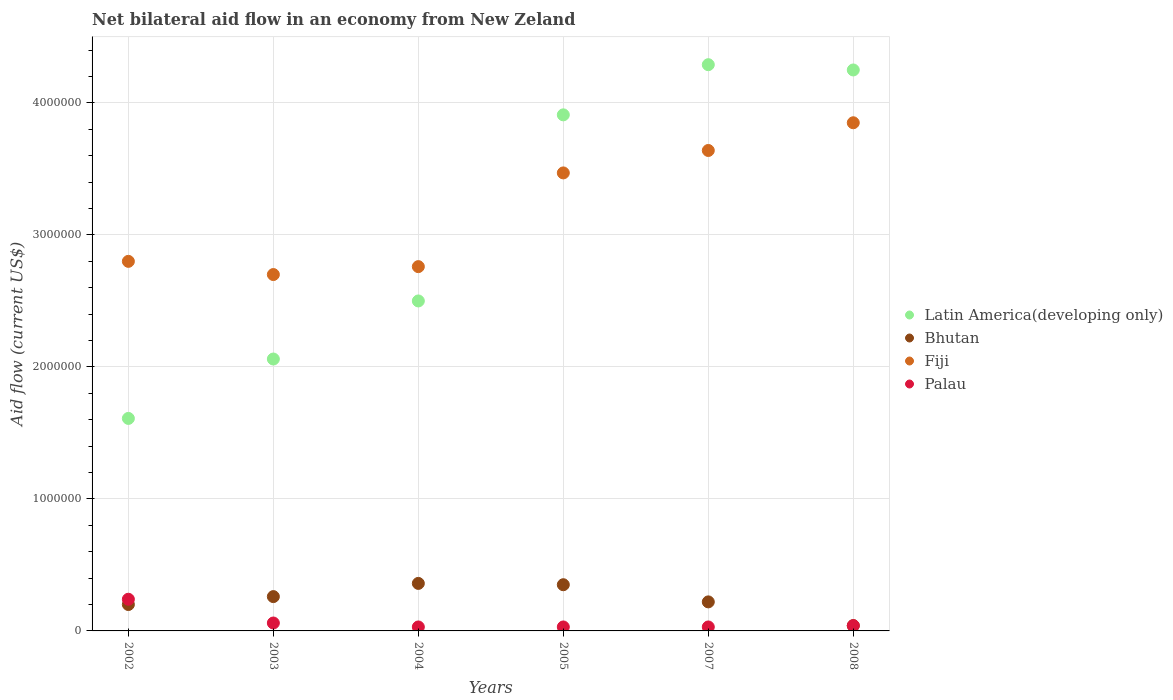How many different coloured dotlines are there?
Keep it short and to the point. 4. What is the net bilateral aid flow in Latin America(developing only) in 2005?
Your response must be concise. 3.91e+06. In which year was the net bilateral aid flow in Fiji minimum?
Your answer should be compact. 2003. What is the total net bilateral aid flow in Fiji in the graph?
Your answer should be very brief. 1.92e+07. What is the difference between the net bilateral aid flow in Fiji in 2004 and the net bilateral aid flow in Bhutan in 2007?
Your response must be concise. 2.54e+06. What is the average net bilateral aid flow in Fiji per year?
Keep it short and to the point. 3.20e+06. In the year 2004, what is the difference between the net bilateral aid flow in Palau and net bilateral aid flow in Bhutan?
Your response must be concise. -3.30e+05. What is the ratio of the net bilateral aid flow in Latin America(developing only) in 2005 to that in 2008?
Ensure brevity in your answer.  0.92. What is the difference between the highest and the lowest net bilateral aid flow in Latin America(developing only)?
Make the answer very short. 2.68e+06. In how many years, is the net bilateral aid flow in Fiji greater than the average net bilateral aid flow in Fiji taken over all years?
Give a very brief answer. 3. Does the net bilateral aid flow in Bhutan monotonically increase over the years?
Your answer should be compact. No. Is the net bilateral aid flow in Bhutan strictly greater than the net bilateral aid flow in Fiji over the years?
Your answer should be very brief. No. What is the difference between two consecutive major ticks on the Y-axis?
Provide a succinct answer. 1.00e+06. Are the values on the major ticks of Y-axis written in scientific E-notation?
Your response must be concise. No. Does the graph contain any zero values?
Provide a succinct answer. No. How many legend labels are there?
Keep it short and to the point. 4. How are the legend labels stacked?
Offer a terse response. Vertical. What is the title of the graph?
Offer a terse response. Net bilateral aid flow in an economy from New Zeland. What is the label or title of the Y-axis?
Your response must be concise. Aid flow (current US$). What is the Aid flow (current US$) in Latin America(developing only) in 2002?
Give a very brief answer. 1.61e+06. What is the Aid flow (current US$) in Fiji in 2002?
Make the answer very short. 2.80e+06. What is the Aid flow (current US$) in Palau in 2002?
Make the answer very short. 2.40e+05. What is the Aid flow (current US$) in Latin America(developing only) in 2003?
Offer a terse response. 2.06e+06. What is the Aid flow (current US$) of Bhutan in 2003?
Offer a terse response. 2.60e+05. What is the Aid flow (current US$) in Fiji in 2003?
Your response must be concise. 2.70e+06. What is the Aid flow (current US$) in Palau in 2003?
Give a very brief answer. 6.00e+04. What is the Aid flow (current US$) of Latin America(developing only) in 2004?
Give a very brief answer. 2.50e+06. What is the Aid flow (current US$) in Fiji in 2004?
Provide a short and direct response. 2.76e+06. What is the Aid flow (current US$) of Latin America(developing only) in 2005?
Provide a short and direct response. 3.91e+06. What is the Aid flow (current US$) of Bhutan in 2005?
Provide a short and direct response. 3.50e+05. What is the Aid flow (current US$) of Fiji in 2005?
Give a very brief answer. 3.47e+06. What is the Aid flow (current US$) in Latin America(developing only) in 2007?
Ensure brevity in your answer.  4.29e+06. What is the Aid flow (current US$) in Fiji in 2007?
Offer a terse response. 3.64e+06. What is the Aid flow (current US$) in Palau in 2007?
Keep it short and to the point. 3.00e+04. What is the Aid flow (current US$) in Latin America(developing only) in 2008?
Make the answer very short. 4.25e+06. What is the Aid flow (current US$) of Bhutan in 2008?
Your response must be concise. 4.00e+04. What is the Aid flow (current US$) of Fiji in 2008?
Make the answer very short. 3.85e+06. What is the Aid flow (current US$) of Palau in 2008?
Give a very brief answer. 4.00e+04. Across all years, what is the maximum Aid flow (current US$) in Latin America(developing only)?
Give a very brief answer. 4.29e+06. Across all years, what is the maximum Aid flow (current US$) in Bhutan?
Offer a very short reply. 3.60e+05. Across all years, what is the maximum Aid flow (current US$) of Fiji?
Your response must be concise. 3.85e+06. Across all years, what is the maximum Aid flow (current US$) in Palau?
Your answer should be very brief. 2.40e+05. Across all years, what is the minimum Aid flow (current US$) in Latin America(developing only)?
Offer a very short reply. 1.61e+06. Across all years, what is the minimum Aid flow (current US$) of Fiji?
Provide a succinct answer. 2.70e+06. Across all years, what is the minimum Aid flow (current US$) of Palau?
Your answer should be compact. 3.00e+04. What is the total Aid flow (current US$) of Latin America(developing only) in the graph?
Provide a short and direct response. 1.86e+07. What is the total Aid flow (current US$) of Bhutan in the graph?
Give a very brief answer. 1.43e+06. What is the total Aid flow (current US$) in Fiji in the graph?
Provide a succinct answer. 1.92e+07. What is the total Aid flow (current US$) of Palau in the graph?
Your answer should be compact. 4.30e+05. What is the difference between the Aid flow (current US$) of Latin America(developing only) in 2002 and that in 2003?
Your answer should be compact. -4.50e+05. What is the difference between the Aid flow (current US$) of Latin America(developing only) in 2002 and that in 2004?
Make the answer very short. -8.90e+05. What is the difference between the Aid flow (current US$) of Bhutan in 2002 and that in 2004?
Your response must be concise. -1.60e+05. What is the difference between the Aid flow (current US$) in Palau in 2002 and that in 2004?
Keep it short and to the point. 2.10e+05. What is the difference between the Aid flow (current US$) of Latin America(developing only) in 2002 and that in 2005?
Offer a terse response. -2.30e+06. What is the difference between the Aid flow (current US$) of Bhutan in 2002 and that in 2005?
Make the answer very short. -1.50e+05. What is the difference between the Aid flow (current US$) of Fiji in 2002 and that in 2005?
Your response must be concise. -6.70e+05. What is the difference between the Aid flow (current US$) in Palau in 2002 and that in 2005?
Give a very brief answer. 2.10e+05. What is the difference between the Aid flow (current US$) in Latin America(developing only) in 2002 and that in 2007?
Provide a short and direct response. -2.68e+06. What is the difference between the Aid flow (current US$) of Bhutan in 2002 and that in 2007?
Keep it short and to the point. -2.00e+04. What is the difference between the Aid flow (current US$) in Fiji in 2002 and that in 2007?
Provide a succinct answer. -8.40e+05. What is the difference between the Aid flow (current US$) in Palau in 2002 and that in 2007?
Provide a succinct answer. 2.10e+05. What is the difference between the Aid flow (current US$) in Latin America(developing only) in 2002 and that in 2008?
Offer a very short reply. -2.64e+06. What is the difference between the Aid flow (current US$) of Fiji in 2002 and that in 2008?
Your answer should be very brief. -1.05e+06. What is the difference between the Aid flow (current US$) in Palau in 2002 and that in 2008?
Make the answer very short. 2.00e+05. What is the difference between the Aid flow (current US$) of Latin America(developing only) in 2003 and that in 2004?
Provide a short and direct response. -4.40e+05. What is the difference between the Aid flow (current US$) in Fiji in 2003 and that in 2004?
Give a very brief answer. -6.00e+04. What is the difference between the Aid flow (current US$) in Palau in 2003 and that in 2004?
Make the answer very short. 3.00e+04. What is the difference between the Aid flow (current US$) of Latin America(developing only) in 2003 and that in 2005?
Your response must be concise. -1.85e+06. What is the difference between the Aid flow (current US$) in Fiji in 2003 and that in 2005?
Your answer should be compact. -7.70e+05. What is the difference between the Aid flow (current US$) of Palau in 2003 and that in 2005?
Your response must be concise. 3.00e+04. What is the difference between the Aid flow (current US$) in Latin America(developing only) in 2003 and that in 2007?
Provide a short and direct response. -2.23e+06. What is the difference between the Aid flow (current US$) in Bhutan in 2003 and that in 2007?
Your answer should be compact. 4.00e+04. What is the difference between the Aid flow (current US$) of Fiji in 2003 and that in 2007?
Make the answer very short. -9.40e+05. What is the difference between the Aid flow (current US$) of Palau in 2003 and that in 2007?
Give a very brief answer. 3.00e+04. What is the difference between the Aid flow (current US$) in Latin America(developing only) in 2003 and that in 2008?
Offer a very short reply. -2.19e+06. What is the difference between the Aid flow (current US$) of Bhutan in 2003 and that in 2008?
Give a very brief answer. 2.20e+05. What is the difference between the Aid flow (current US$) of Fiji in 2003 and that in 2008?
Your answer should be compact. -1.15e+06. What is the difference between the Aid flow (current US$) in Palau in 2003 and that in 2008?
Your response must be concise. 2.00e+04. What is the difference between the Aid flow (current US$) in Latin America(developing only) in 2004 and that in 2005?
Offer a very short reply. -1.41e+06. What is the difference between the Aid flow (current US$) of Bhutan in 2004 and that in 2005?
Your answer should be very brief. 10000. What is the difference between the Aid flow (current US$) of Fiji in 2004 and that in 2005?
Offer a terse response. -7.10e+05. What is the difference between the Aid flow (current US$) of Latin America(developing only) in 2004 and that in 2007?
Your answer should be compact. -1.79e+06. What is the difference between the Aid flow (current US$) in Fiji in 2004 and that in 2007?
Your response must be concise. -8.80e+05. What is the difference between the Aid flow (current US$) in Latin America(developing only) in 2004 and that in 2008?
Your response must be concise. -1.75e+06. What is the difference between the Aid flow (current US$) in Fiji in 2004 and that in 2008?
Ensure brevity in your answer.  -1.09e+06. What is the difference between the Aid flow (current US$) in Palau in 2004 and that in 2008?
Offer a terse response. -10000. What is the difference between the Aid flow (current US$) in Latin America(developing only) in 2005 and that in 2007?
Ensure brevity in your answer.  -3.80e+05. What is the difference between the Aid flow (current US$) in Fiji in 2005 and that in 2007?
Make the answer very short. -1.70e+05. What is the difference between the Aid flow (current US$) in Palau in 2005 and that in 2007?
Offer a very short reply. 0. What is the difference between the Aid flow (current US$) of Latin America(developing only) in 2005 and that in 2008?
Provide a succinct answer. -3.40e+05. What is the difference between the Aid flow (current US$) of Bhutan in 2005 and that in 2008?
Give a very brief answer. 3.10e+05. What is the difference between the Aid flow (current US$) of Fiji in 2005 and that in 2008?
Your answer should be compact. -3.80e+05. What is the difference between the Aid flow (current US$) of Latin America(developing only) in 2007 and that in 2008?
Your response must be concise. 4.00e+04. What is the difference between the Aid flow (current US$) of Bhutan in 2007 and that in 2008?
Your answer should be compact. 1.80e+05. What is the difference between the Aid flow (current US$) of Fiji in 2007 and that in 2008?
Keep it short and to the point. -2.10e+05. What is the difference between the Aid flow (current US$) of Latin America(developing only) in 2002 and the Aid flow (current US$) of Bhutan in 2003?
Your answer should be compact. 1.35e+06. What is the difference between the Aid flow (current US$) of Latin America(developing only) in 2002 and the Aid flow (current US$) of Fiji in 2003?
Offer a terse response. -1.09e+06. What is the difference between the Aid flow (current US$) of Latin America(developing only) in 2002 and the Aid flow (current US$) of Palau in 2003?
Your answer should be compact. 1.55e+06. What is the difference between the Aid flow (current US$) in Bhutan in 2002 and the Aid flow (current US$) in Fiji in 2003?
Make the answer very short. -2.50e+06. What is the difference between the Aid flow (current US$) in Bhutan in 2002 and the Aid flow (current US$) in Palau in 2003?
Provide a succinct answer. 1.40e+05. What is the difference between the Aid flow (current US$) of Fiji in 2002 and the Aid flow (current US$) of Palau in 2003?
Offer a terse response. 2.74e+06. What is the difference between the Aid flow (current US$) of Latin America(developing only) in 2002 and the Aid flow (current US$) of Bhutan in 2004?
Make the answer very short. 1.25e+06. What is the difference between the Aid flow (current US$) in Latin America(developing only) in 2002 and the Aid flow (current US$) in Fiji in 2004?
Offer a terse response. -1.15e+06. What is the difference between the Aid flow (current US$) in Latin America(developing only) in 2002 and the Aid flow (current US$) in Palau in 2004?
Make the answer very short. 1.58e+06. What is the difference between the Aid flow (current US$) in Bhutan in 2002 and the Aid flow (current US$) in Fiji in 2004?
Provide a succinct answer. -2.56e+06. What is the difference between the Aid flow (current US$) of Fiji in 2002 and the Aid flow (current US$) of Palau in 2004?
Make the answer very short. 2.77e+06. What is the difference between the Aid flow (current US$) in Latin America(developing only) in 2002 and the Aid flow (current US$) in Bhutan in 2005?
Offer a very short reply. 1.26e+06. What is the difference between the Aid flow (current US$) in Latin America(developing only) in 2002 and the Aid flow (current US$) in Fiji in 2005?
Your answer should be compact. -1.86e+06. What is the difference between the Aid flow (current US$) of Latin America(developing only) in 2002 and the Aid flow (current US$) of Palau in 2005?
Ensure brevity in your answer.  1.58e+06. What is the difference between the Aid flow (current US$) of Bhutan in 2002 and the Aid flow (current US$) of Fiji in 2005?
Provide a succinct answer. -3.27e+06. What is the difference between the Aid flow (current US$) of Bhutan in 2002 and the Aid flow (current US$) of Palau in 2005?
Keep it short and to the point. 1.70e+05. What is the difference between the Aid flow (current US$) in Fiji in 2002 and the Aid flow (current US$) in Palau in 2005?
Provide a succinct answer. 2.77e+06. What is the difference between the Aid flow (current US$) of Latin America(developing only) in 2002 and the Aid flow (current US$) of Bhutan in 2007?
Your answer should be very brief. 1.39e+06. What is the difference between the Aid flow (current US$) of Latin America(developing only) in 2002 and the Aid flow (current US$) of Fiji in 2007?
Ensure brevity in your answer.  -2.03e+06. What is the difference between the Aid flow (current US$) of Latin America(developing only) in 2002 and the Aid flow (current US$) of Palau in 2007?
Keep it short and to the point. 1.58e+06. What is the difference between the Aid flow (current US$) in Bhutan in 2002 and the Aid flow (current US$) in Fiji in 2007?
Keep it short and to the point. -3.44e+06. What is the difference between the Aid flow (current US$) of Fiji in 2002 and the Aid flow (current US$) of Palau in 2007?
Your answer should be very brief. 2.77e+06. What is the difference between the Aid flow (current US$) in Latin America(developing only) in 2002 and the Aid flow (current US$) in Bhutan in 2008?
Ensure brevity in your answer.  1.57e+06. What is the difference between the Aid flow (current US$) in Latin America(developing only) in 2002 and the Aid flow (current US$) in Fiji in 2008?
Give a very brief answer. -2.24e+06. What is the difference between the Aid flow (current US$) in Latin America(developing only) in 2002 and the Aid flow (current US$) in Palau in 2008?
Your response must be concise. 1.57e+06. What is the difference between the Aid flow (current US$) in Bhutan in 2002 and the Aid flow (current US$) in Fiji in 2008?
Ensure brevity in your answer.  -3.65e+06. What is the difference between the Aid flow (current US$) of Fiji in 2002 and the Aid flow (current US$) of Palau in 2008?
Ensure brevity in your answer.  2.76e+06. What is the difference between the Aid flow (current US$) of Latin America(developing only) in 2003 and the Aid flow (current US$) of Bhutan in 2004?
Your answer should be compact. 1.70e+06. What is the difference between the Aid flow (current US$) of Latin America(developing only) in 2003 and the Aid flow (current US$) of Fiji in 2004?
Offer a terse response. -7.00e+05. What is the difference between the Aid flow (current US$) in Latin America(developing only) in 2003 and the Aid flow (current US$) in Palau in 2004?
Your answer should be compact. 2.03e+06. What is the difference between the Aid flow (current US$) of Bhutan in 2003 and the Aid flow (current US$) of Fiji in 2004?
Offer a terse response. -2.50e+06. What is the difference between the Aid flow (current US$) in Fiji in 2003 and the Aid flow (current US$) in Palau in 2004?
Keep it short and to the point. 2.67e+06. What is the difference between the Aid flow (current US$) in Latin America(developing only) in 2003 and the Aid flow (current US$) in Bhutan in 2005?
Keep it short and to the point. 1.71e+06. What is the difference between the Aid flow (current US$) in Latin America(developing only) in 2003 and the Aid flow (current US$) in Fiji in 2005?
Offer a terse response. -1.41e+06. What is the difference between the Aid flow (current US$) of Latin America(developing only) in 2003 and the Aid flow (current US$) of Palau in 2005?
Keep it short and to the point. 2.03e+06. What is the difference between the Aid flow (current US$) of Bhutan in 2003 and the Aid flow (current US$) of Fiji in 2005?
Give a very brief answer. -3.21e+06. What is the difference between the Aid flow (current US$) of Fiji in 2003 and the Aid flow (current US$) of Palau in 2005?
Ensure brevity in your answer.  2.67e+06. What is the difference between the Aid flow (current US$) of Latin America(developing only) in 2003 and the Aid flow (current US$) of Bhutan in 2007?
Offer a terse response. 1.84e+06. What is the difference between the Aid flow (current US$) of Latin America(developing only) in 2003 and the Aid flow (current US$) of Fiji in 2007?
Give a very brief answer. -1.58e+06. What is the difference between the Aid flow (current US$) in Latin America(developing only) in 2003 and the Aid flow (current US$) in Palau in 2007?
Keep it short and to the point. 2.03e+06. What is the difference between the Aid flow (current US$) in Bhutan in 2003 and the Aid flow (current US$) in Fiji in 2007?
Offer a very short reply. -3.38e+06. What is the difference between the Aid flow (current US$) of Bhutan in 2003 and the Aid flow (current US$) of Palau in 2007?
Offer a terse response. 2.30e+05. What is the difference between the Aid flow (current US$) in Fiji in 2003 and the Aid flow (current US$) in Palau in 2007?
Make the answer very short. 2.67e+06. What is the difference between the Aid flow (current US$) of Latin America(developing only) in 2003 and the Aid flow (current US$) of Bhutan in 2008?
Offer a very short reply. 2.02e+06. What is the difference between the Aid flow (current US$) in Latin America(developing only) in 2003 and the Aid flow (current US$) in Fiji in 2008?
Your response must be concise. -1.79e+06. What is the difference between the Aid flow (current US$) of Latin America(developing only) in 2003 and the Aid flow (current US$) of Palau in 2008?
Provide a succinct answer. 2.02e+06. What is the difference between the Aid flow (current US$) in Bhutan in 2003 and the Aid flow (current US$) in Fiji in 2008?
Your answer should be compact. -3.59e+06. What is the difference between the Aid flow (current US$) in Fiji in 2003 and the Aid flow (current US$) in Palau in 2008?
Ensure brevity in your answer.  2.66e+06. What is the difference between the Aid flow (current US$) in Latin America(developing only) in 2004 and the Aid flow (current US$) in Bhutan in 2005?
Your response must be concise. 2.15e+06. What is the difference between the Aid flow (current US$) in Latin America(developing only) in 2004 and the Aid flow (current US$) in Fiji in 2005?
Provide a succinct answer. -9.70e+05. What is the difference between the Aid flow (current US$) in Latin America(developing only) in 2004 and the Aid flow (current US$) in Palau in 2005?
Provide a short and direct response. 2.47e+06. What is the difference between the Aid flow (current US$) of Bhutan in 2004 and the Aid flow (current US$) of Fiji in 2005?
Offer a very short reply. -3.11e+06. What is the difference between the Aid flow (current US$) of Fiji in 2004 and the Aid flow (current US$) of Palau in 2005?
Your answer should be compact. 2.73e+06. What is the difference between the Aid flow (current US$) in Latin America(developing only) in 2004 and the Aid flow (current US$) in Bhutan in 2007?
Offer a terse response. 2.28e+06. What is the difference between the Aid flow (current US$) in Latin America(developing only) in 2004 and the Aid flow (current US$) in Fiji in 2007?
Keep it short and to the point. -1.14e+06. What is the difference between the Aid flow (current US$) in Latin America(developing only) in 2004 and the Aid flow (current US$) in Palau in 2007?
Ensure brevity in your answer.  2.47e+06. What is the difference between the Aid flow (current US$) in Bhutan in 2004 and the Aid flow (current US$) in Fiji in 2007?
Your answer should be very brief. -3.28e+06. What is the difference between the Aid flow (current US$) of Bhutan in 2004 and the Aid flow (current US$) of Palau in 2007?
Keep it short and to the point. 3.30e+05. What is the difference between the Aid flow (current US$) of Fiji in 2004 and the Aid flow (current US$) of Palau in 2007?
Your answer should be compact. 2.73e+06. What is the difference between the Aid flow (current US$) of Latin America(developing only) in 2004 and the Aid flow (current US$) of Bhutan in 2008?
Your response must be concise. 2.46e+06. What is the difference between the Aid flow (current US$) in Latin America(developing only) in 2004 and the Aid flow (current US$) in Fiji in 2008?
Offer a terse response. -1.35e+06. What is the difference between the Aid flow (current US$) in Latin America(developing only) in 2004 and the Aid flow (current US$) in Palau in 2008?
Ensure brevity in your answer.  2.46e+06. What is the difference between the Aid flow (current US$) of Bhutan in 2004 and the Aid flow (current US$) of Fiji in 2008?
Make the answer very short. -3.49e+06. What is the difference between the Aid flow (current US$) of Bhutan in 2004 and the Aid flow (current US$) of Palau in 2008?
Make the answer very short. 3.20e+05. What is the difference between the Aid flow (current US$) in Fiji in 2004 and the Aid flow (current US$) in Palau in 2008?
Offer a terse response. 2.72e+06. What is the difference between the Aid flow (current US$) of Latin America(developing only) in 2005 and the Aid flow (current US$) of Bhutan in 2007?
Ensure brevity in your answer.  3.69e+06. What is the difference between the Aid flow (current US$) in Latin America(developing only) in 2005 and the Aid flow (current US$) in Fiji in 2007?
Make the answer very short. 2.70e+05. What is the difference between the Aid flow (current US$) of Latin America(developing only) in 2005 and the Aid flow (current US$) of Palau in 2007?
Make the answer very short. 3.88e+06. What is the difference between the Aid flow (current US$) of Bhutan in 2005 and the Aid flow (current US$) of Fiji in 2007?
Your answer should be compact. -3.29e+06. What is the difference between the Aid flow (current US$) in Fiji in 2005 and the Aid flow (current US$) in Palau in 2007?
Keep it short and to the point. 3.44e+06. What is the difference between the Aid flow (current US$) in Latin America(developing only) in 2005 and the Aid flow (current US$) in Bhutan in 2008?
Make the answer very short. 3.87e+06. What is the difference between the Aid flow (current US$) of Latin America(developing only) in 2005 and the Aid flow (current US$) of Fiji in 2008?
Your response must be concise. 6.00e+04. What is the difference between the Aid flow (current US$) of Latin America(developing only) in 2005 and the Aid flow (current US$) of Palau in 2008?
Offer a terse response. 3.87e+06. What is the difference between the Aid flow (current US$) of Bhutan in 2005 and the Aid flow (current US$) of Fiji in 2008?
Your answer should be very brief. -3.50e+06. What is the difference between the Aid flow (current US$) in Fiji in 2005 and the Aid flow (current US$) in Palau in 2008?
Offer a very short reply. 3.43e+06. What is the difference between the Aid flow (current US$) in Latin America(developing only) in 2007 and the Aid flow (current US$) in Bhutan in 2008?
Your answer should be very brief. 4.25e+06. What is the difference between the Aid flow (current US$) in Latin America(developing only) in 2007 and the Aid flow (current US$) in Palau in 2008?
Offer a terse response. 4.25e+06. What is the difference between the Aid flow (current US$) in Bhutan in 2007 and the Aid flow (current US$) in Fiji in 2008?
Your response must be concise. -3.63e+06. What is the difference between the Aid flow (current US$) in Fiji in 2007 and the Aid flow (current US$) in Palau in 2008?
Keep it short and to the point. 3.60e+06. What is the average Aid flow (current US$) in Latin America(developing only) per year?
Keep it short and to the point. 3.10e+06. What is the average Aid flow (current US$) of Bhutan per year?
Your answer should be compact. 2.38e+05. What is the average Aid flow (current US$) of Fiji per year?
Offer a very short reply. 3.20e+06. What is the average Aid flow (current US$) in Palau per year?
Offer a very short reply. 7.17e+04. In the year 2002, what is the difference between the Aid flow (current US$) of Latin America(developing only) and Aid flow (current US$) of Bhutan?
Offer a very short reply. 1.41e+06. In the year 2002, what is the difference between the Aid flow (current US$) in Latin America(developing only) and Aid flow (current US$) in Fiji?
Ensure brevity in your answer.  -1.19e+06. In the year 2002, what is the difference between the Aid flow (current US$) of Latin America(developing only) and Aid flow (current US$) of Palau?
Provide a succinct answer. 1.37e+06. In the year 2002, what is the difference between the Aid flow (current US$) in Bhutan and Aid flow (current US$) in Fiji?
Give a very brief answer. -2.60e+06. In the year 2002, what is the difference between the Aid flow (current US$) in Fiji and Aid flow (current US$) in Palau?
Keep it short and to the point. 2.56e+06. In the year 2003, what is the difference between the Aid flow (current US$) in Latin America(developing only) and Aid flow (current US$) in Bhutan?
Provide a short and direct response. 1.80e+06. In the year 2003, what is the difference between the Aid flow (current US$) in Latin America(developing only) and Aid flow (current US$) in Fiji?
Offer a terse response. -6.40e+05. In the year 2003, what is the difference between the Aid flow (current US$) of Latin America(developing only) and Aid flow (current US$) of Palau?
Keep it short and to the point. 2.00e+06. In the year 2003, what is the difference between the Aid flow (current US$) of Bhutan and Aid flow (current US$) of Fiji?
Offer a very short reply. -2.44e+06. In the year 2003, what is the difference between the Aid flow (current US$) of Bhutan and Aid flow (current US$) of Palau?
Ensure brevity in your answer.  2.00e+05. In the year 2003, what is the difference between the Aid flow (current US$) in Fiji and Aid flow (current US$) in Palau?
Provide a succinct answer. 2.64e+06. In the year 2004, what is the difference between the Aid flow (current US$) of Latin America(developing only) and Aid flow (current US$) of Bhutan?
Your response must be concise. 2.14e+06. In the year 2004, what is the difference between the Aid flow (current US$) in Latin America(developing only) and Aid flow (current US$) in Fiji?
Your response must be concise. -2.60e+05. In the year 2004, what is the difference between the Aid flow (current US$) of Latin America(developing only) and Aid flow (current US$) of Palau?
Make the answer very short. 2.47e+06. In the year 2004, what is the difference between the Aid flow (current US$) in Bhutan and Aid flow (current US$) in Fiji?
Offer a very short reply. -2.40e+06. In the year 2004, what is the difference between the Aid flow (current US$) in Fiji and Aid flow (current US$) in Palau?
Your response must be concise. 2.73e+06. In the year 2005, what is the difference between the Aid flow (current US$) in Latin America(developing only) and Aid flow (current US$) in Bhutan?
Your answer should be very brief. 3.56e+06. In the year 2005, what is the difference between the Aid flow (current US$) of Latin America(developing only) and Aid flow (current US$) of Fiji?
Your answer should be compact. 4.40e+05. In the year 2005, what is the difference between the Aid flow (current US$) in Latin America(developing only) and Aid flow (current US$) in Palau?
Your answer should be compact. 3.88e+06. In the year 2005, what is the difference between the Aid flow (current US$) of Bhutan and Aid flow (current US$) of Fiji?
Offer a terse response. -3.12e+06. In the year 2005, what is the difference between the Aid flow (current US$) of Fiji and Aid flow (current US$) of Palau?
Make the answer very short. 3.44e+06. In the year 2007, what is the difference between the Aid flow (current US$) in Latin America(developing only) and Aid flow (current US$) in Bhutan?
Make the answer very short. 4.07e+06. In the year 2007, what is the difference between the Aid flow (current US$) of Latin America(developing only) and Aid flow (current US$) of Fiji?
Make the answer very short. 6.50e+05. In the year 2007, what is the difference between the Aid flow (current US$) of Latin America(developing only) and Aid flow (current US$) of Palau?
Provide a short and direct response. 4.26e+06. In the year 2007, what is the difference between the Aid flow (current US$) of Bhutan and Aid flow (current US$) of Fiji?
Ensure brevity in your answer.  -3.42e+06. In the year 2007, what is the difference between the Aid flow (current US$) in Fiji and Aid flow (current US$) in Palau?
Keep it short and to the point. 3.61e+06. In the year 2008, what is the difference between the Aid flow (current US$) of Latin America(developing only) and Aid flow (current US$) of Bhutan?
Provide a short and direct response. 4.21e+06. In the year 2008, what is the difference between the Aid flow (current US$) of Latin America(developing only) and Aid flow (current US$) of Palau?
Make the answer very short. 4.21e+06. In the year 2008, what is the difference between the Aid flow (current US$) of Bhutan and Aid flow (current US$) of Fiji?
Provide a succinct answer. -3.81e+06. In the year 2008, what is the difference between the Aid flow (current US$) in Fiji and Aid flow (current US$) in Palau?
Your answer should be very brief. 3.81e+06. What is the ratio of the Aid flow (current US$) in Latin America(developing only) in 2002 to that in 2003?
Your answer should be very brief. 0.78. What is the ratio of the Aid flow (current US$) of Bhutan in 2002 to that in 2003?
Your response must be concise. 0.77. What is the ratio of the Aid flow (current US$) of Fiji in 2002 to that in 2003?
Keep it short and to the point. 1.04. What is the ratio of the Aid flow (current US$) in Palau in 2002 to that in 2003?
Provide a short and direct response. 4. What is the ratio of the Aid flow (current US$) of Latin America(developing only) in 2002 to that in 2004?
Ensure brevity in your answer.  0.64. What is the ratio of the Aid flow (current US$) of Bhutan in 2002 to that in 2004?
Make the answer very short. 0.56. What is the ratio of the Aid flow (current US$) in Fiji in 2002 to that in 2004?
Your response must be concise. 1.01. What is the ratio of the Aid flow (current US$) of Palau in 2002 to that in 2004?
Make the answer very short. 8. What is the ratio of the Aid flow (current US$) of Latin America(developing only) in 2002 to that in 2005?
Your answer should be compact. 0.41. What is the ratio of the Aid flow (current US$) in Fiji in 2002 to that in 2005?
Offer a very short reply. 0.81. What is the ratio of the Aid flow (current US$) in Latin America(developing only) in 2002 to that in 2007?
Your answer should be compact. 0.38. What is the ratio of the Aid flow (current US$) of Fiji in 2002 to that in 2007?
Make the answer very short. 0.77. What is the ratio of the Aid flow (current US$) in Palau in 2002 to that in 2007?
Your answer should be very brief. 8. What is the ratio of the Aid flow (current US$) of Latin America(developing only) in 2002 to that in 2008?
Your answer should be very brief. 0.38. What is the ratio of the Aid flow (current US$) in Bhutan in 2002 to that in 2008?
Provide a short and direct response. 5. What is the ratio of the Aid flow (current US$) in Fiji in 2002 to that in 2008?
Ensure brevity in your answer.  0.73. What is the ratio of the Aid flow (current US$) in Palau in 2002 to that in 2008?
Your answer should be very brief. 6. What is the ratio of the Aid flow (current US$) of Latin America(developing only) in 2003 to that in 2004?
Ensure brevity in your answer.  0.82. What is the ratio of the Aid flow (current US$) in Bhutan in 2003 to that in 2004?
Ensure brevity in your answer.  0.72. What is the ratio of the Aid flow (current US$) of Fiji in 2003 to that in 2004?
Your response must be concise. 0.98. What is the ratio of the Aid flow (current US$) in Latin America(developing only) in 2003 to that in 2005?
Your answer should be compact. 0.53. What is the ratio of the Aid flow (current US$) in Bhutan in 2003 to that in 2005?
Your response must be concise. 0.74. What is the ratio of the Aid flow (current US$) in Fiji in 2003 to that in 2005?
Your answer should be very brief. 0.78. What is the ratio of the Aid flow (current US$) of Latin America(developing only) in 2003 to that in 2007?
Offer a terse response. 0.48. What is the ratio of the Aid flow (current US$) in Bhutan in 2003 to that in 2007?
Your response must be concise. 1.18. What is the ratio of the Aid flow (current US$) of Fiji in 2003 to that in 2007?
Provide a succinct answer. 0.74. What is the ratio of the Aid flow (current US$) of Latin America(developing only) in 2003 to that in 2008?
Offer a very short reply. 0.48. What is the ratio of the Aid flow (current US$) of Bhutan in 2003 to that in 2008?
Your answer should be very brief. 6.5. What is the ratio of the Aid flow (current US$) of Fiji in 2003 to that in 2008?
Offer a very short reply. 0.7. What is the ratio of the Aid flow (current US$) in Palau in 2003 to that in 2008?
Ensure brevity in your answer.  1.5. What is the ratio of the Aid flow (current US$) of Latin America(developing only) in 2004 to that in 2005?
Make the answer very short. 0.64. What is the ratio of the Aid flow (current US$) in Bhutan in 2004 to that in 2005?
Your answer should be compact. 1.03. What is the ratio of the Aid flow (current US$) of Fiji in 2004 to that in 2005?
Your answer should be very brief. 0.8. What is the ratio of the Aid flow (current US$) in Palau in 2004 to that in 2005?
Keep it short and to the point. 1. What is the ratio of the Aid flow (current US$) of Latin America(developing only) in 2004 to that in 2007?
Provide a short and direct response. 0.58. What is the ratio of the Aid flow (current US$) in Bhutan in 2004 to that in 2007?
Your answer should be very brief. 1.64. What is the ratio of the Aid flow (current US$) in Fiji in 2004 to that in 2007?
Provide a short and direct response. 0.76. What is the ratio of the Aid flow (current US$) in Latin America(developing only) in 2004 to that in 2008?
Your answer should be very brief. 0.59. What is the ratio of the Aid flow (current US$) of Fiji in 2004 to that in 2008?
Provide a succinct answer. 0.72. What is the ratio of the Aid flow (current US$) in Palau in 2004 to that in 2008?
Your answer should be very brief. 0.75. What is the ratio of the Aid flow (current US$) of Latin America(developing only) in 2005 to that in 2007?
Your response must be concise. 0.91. What is the ratio of the Aid flow (current US$) of Bhutan in 2005 to that in 2007?
Your answer should be very brief. 1.59. What is the ratio of the Aid flow (current US$) of Fiji in 2005 to that in 2007?
Offer a very short reply. 0.95. What is the ratio of the Aid flow (current US$) in Palau in 2005 to that in 2007?
Your response must be concise. 1. What is the ratio of the Aid flow (current US$) in Bhutan in 2005 to that in 2008?
Provide a succinct answer. 8.75. What is the ratio of the Aid flow (current US$) in Fiji in 2005 to that in 2008?
Your answer should be compact. 0.9. What is the ratio of the Aid flow (current US$) of Palau in 2005 to that in 2008?
Your answer should be very brief. 0.75. What is the ratio of the Aid flow (current US$) in Latin America(developing only) in 2007 to that in 2008?
Your response must be concise. 1.01. What is the ratio of the Aid flow (current US$) in Bhutan in 2007 to that in 2008?
Provide a succinct answer. 5.5. What is the ratio of the Aid flow (current US$) in Fiji in 2007 to that in 2008?
Your response must be concise. 0.95. What is the difference between the highest and the second highest Aid flow (current US$) in Latin America(developing only)?
Provide a short and direct response. 4.00e+04. What is the difference between the highest and the second highest Aid flow (current US$) of Bhutan?
Provide a succinct answer. 10000. What is the difference between the highest and the second highest Aid flow (current US$) in Fiji?
Provide a succinct answer. 2.10e+05. What is the difference between the highest and the lowest Aid flow (current US$) of Latin America(developing only)?
Offer a very short reply. 2.68e+06. What is the difference between the highest and the lowest Aid flow (current US$) in Fiji?
Your answer should be compact. 1.15e+06. 